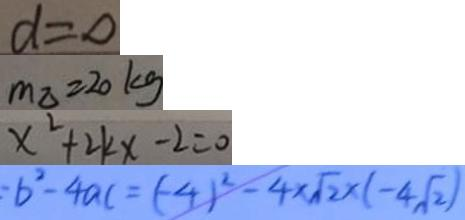Convert formula to latex. <formula><loc_0><loc_0><loc_500><loc_500>d = 0 
 m _ { \Delta } = 2 0 k g 
 x ^ { 2 } + 2 k x - 2 = 0 
 = b ^ { 2 } - 4 a c = ( - 4 ) ^ { 2 } - 4 \times \sqrt { 2 } \times ( - 4 \sqrt { 2 } )</formula> 